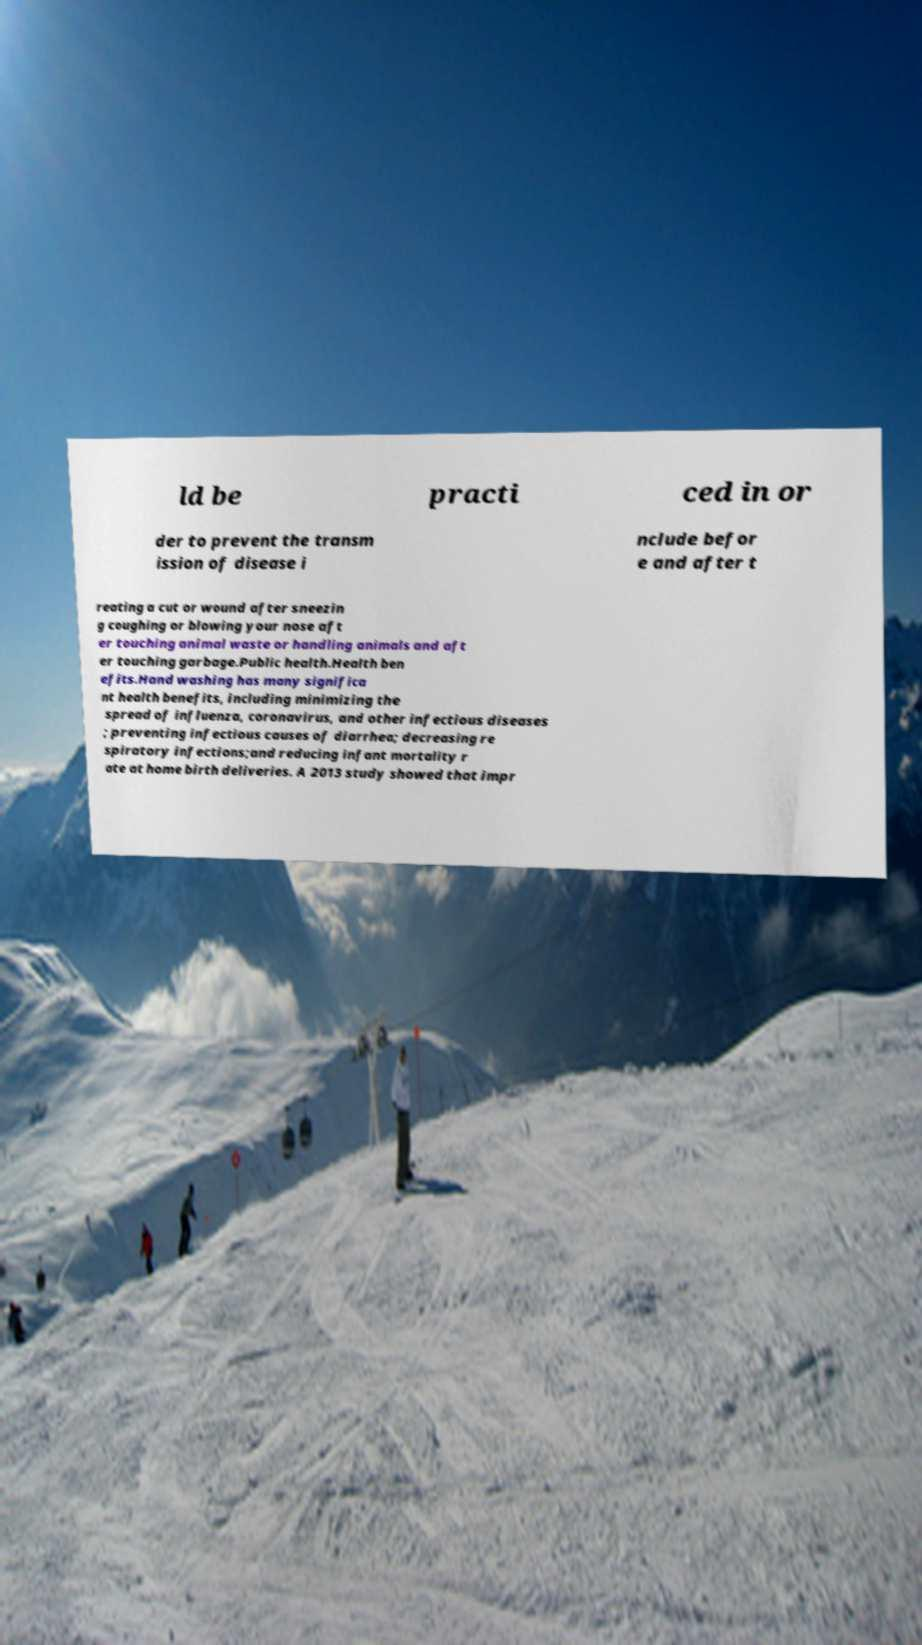Could you assist in decoding the text presented in this image and type it out clearly? ld be practi ced in or der to prevent the transm ission of disease i nclude befor e and after t reating a cut or wound after sneezin g coughing or blowing your nose aft er touching animal waste or handling animals and aft er touching garbage.Public health.Health ben efits.Hand washing has many significa nt health benefits, including minimizing the spread of influenza, coronavirus, and other infectious diseases ; preventing infectious causes of diarrhea; decreasing re spiratory infections;and reducing infant mortality r ate at home birth deliveries. A 2013 study showed that impr 